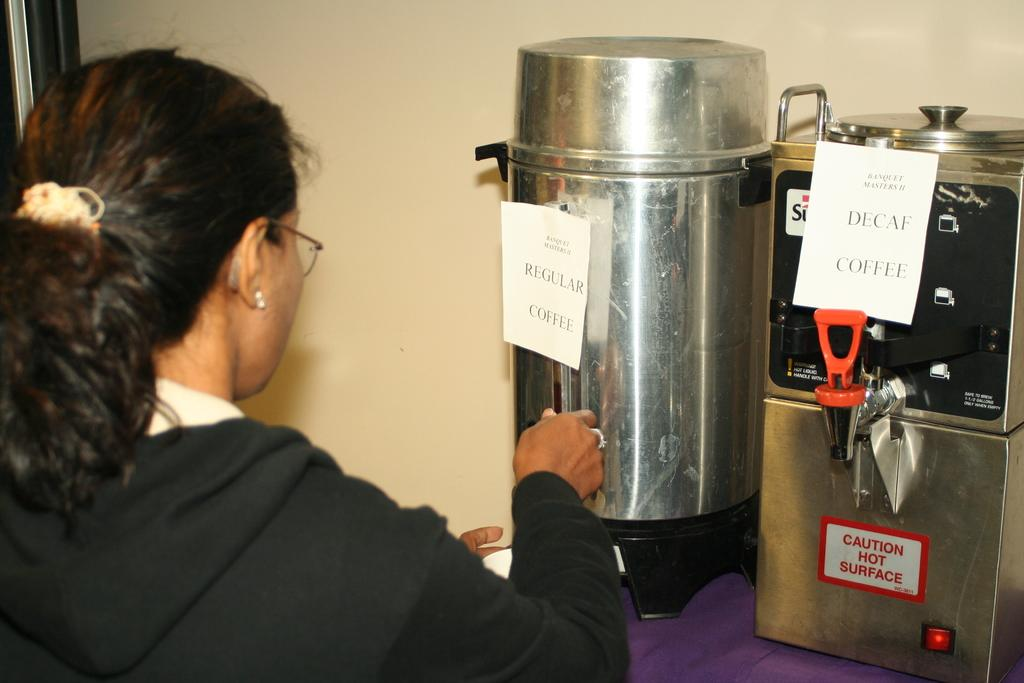Provide a one-sentence caption for the provided image. A woman gets coffee from the regular coffee urn. 